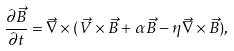<formula> <loc_0><loc_0><loc_500><loc_500>\frac { \partial \vec { B } } { \partial t } = \vec { \nabla } \times ( \vec { V } \times \vec { B } + \alpha \vec { B } - \eta \vec { \nabla } \times \vec { B } ) ,</formula> 